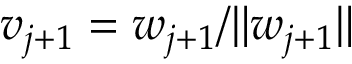<formula> <loc_0><loc_0><loc_500><loc_500>v _ { j + 1 } = w _ { j + 1 } / \| w _ { j + 1 } \|</formula> 